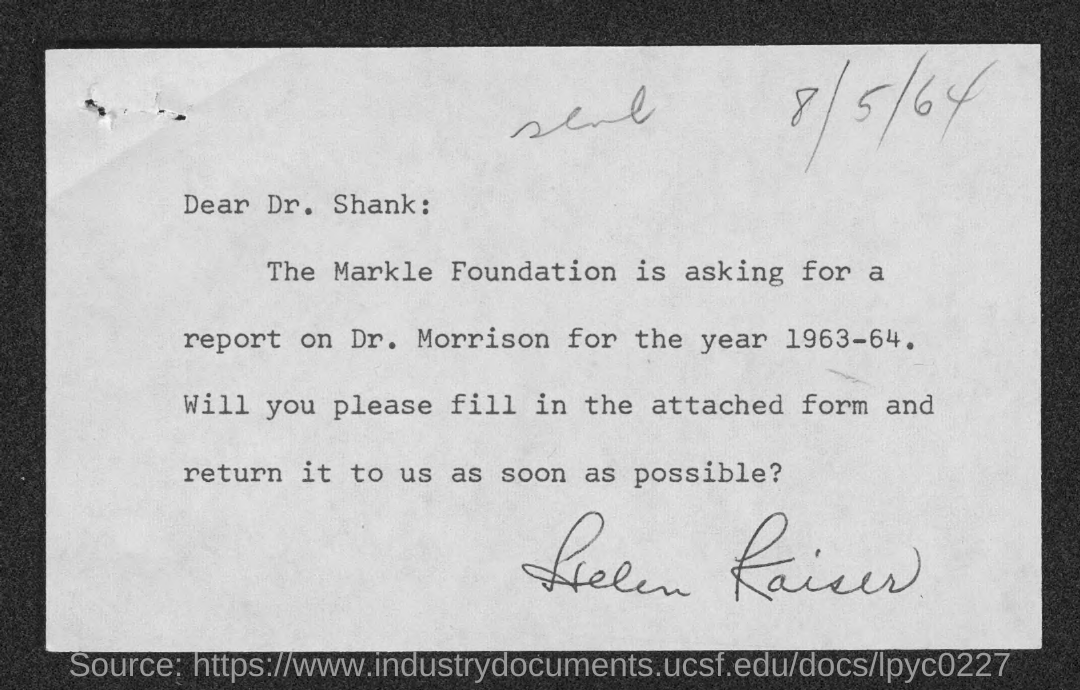Identify some key points in this picture. The letter is addressed to Dr. Shank. The date mentioned at the top of the document is August 5, 1964. 